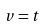Convert formula to latex. <formula><loc_0><loc_0><loc_500><loc_500>v = t</formula> 